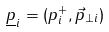<formula> <loc_0><loc_0><loc_500><loc_500>\underline { p } _ { i } = ( p _ { i } ^ { + } , \vec { p } _ { \perp i } )</formula> 